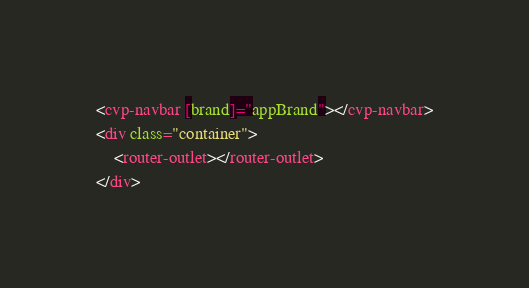Convert code to text. <code><loc_0><loc_0><loc_500><loc_500><_HTML_><cvp-navbar [brand]="appBrand"></cvp-navbar>
<div class="container">
    <router-outlet></router-outlet>
</div>
</code> 